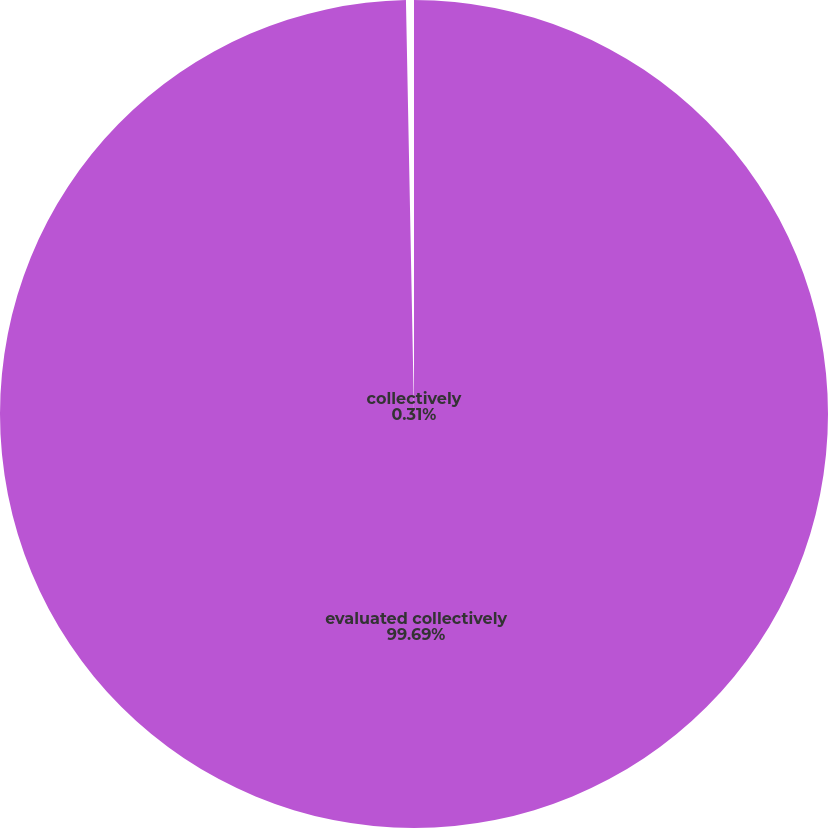Convert chart. <chart><loc_0><loc_0><loc_500><loc_500><pie_chart><fcel>evaluated collectively<fcel>collectively<nl><fcel>99.69%<fcel>0.31%<nl></chart> 